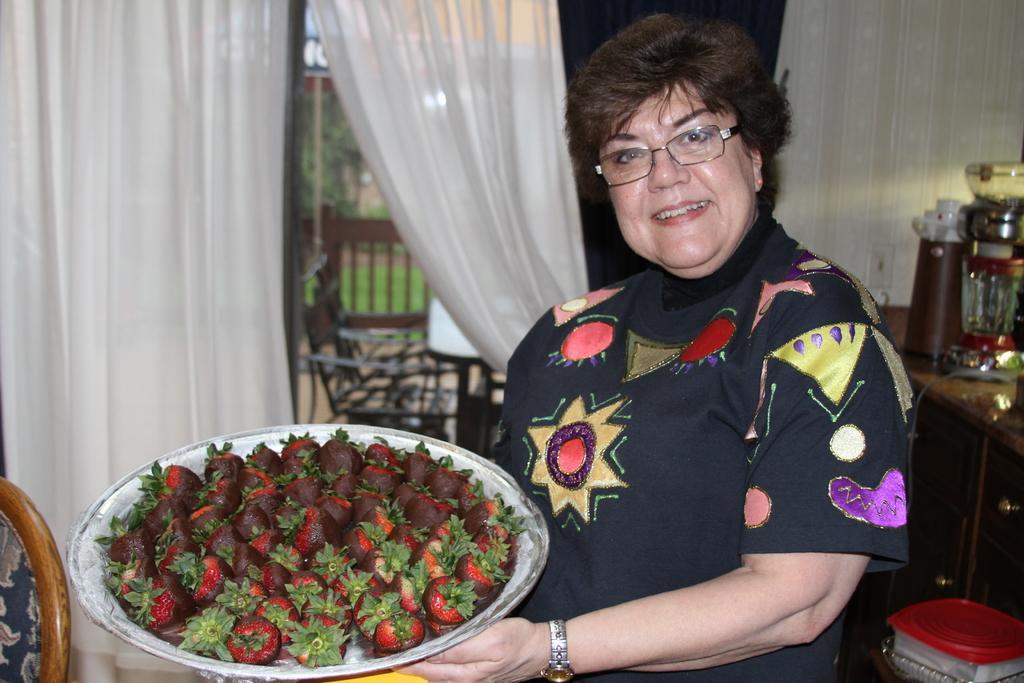Can you describe this image briefly? In the picture there is a woman holding a pan filled with strawberries and the woman is posing for the photo,behind the woman there are some kitchen utensils and beside that there is a balcony. 